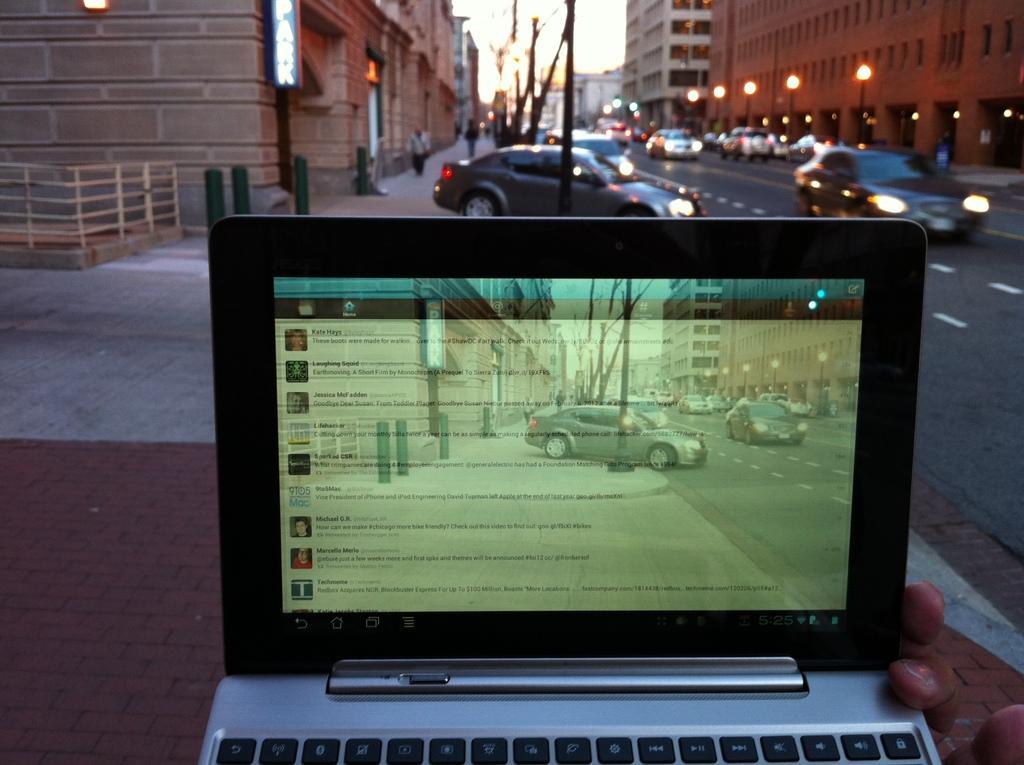Could you give a brief overview of what you see in this image? In this image I can see a person hand holding a laptop which is silver and black in color and in the background I can see few cars on the road, few persons standing on the sidewalk, few poles, few street lights, few buildings and the sky. I can see the view on the laptop screen. 